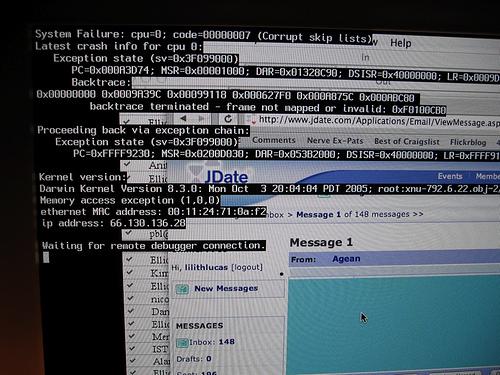What word is to the right of System?
Give a very brief answer. Failure. What's the 2nd word?
Concise answer only. Failure. Is this a keyboard?
Give a very brief answer. No. What dating site is on the computer on?
Quick response, please. Jdate. What is the man coding?
Keep it brief. Computer. 